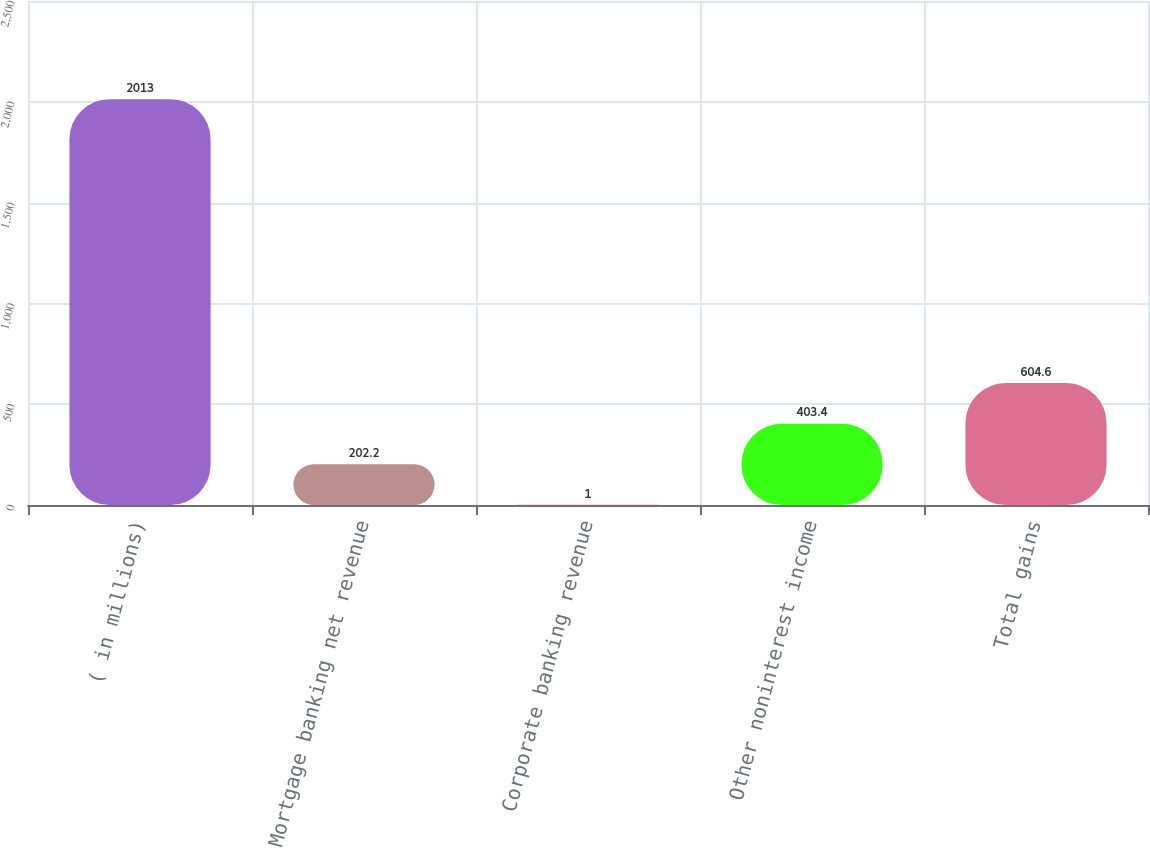Convert chart. <chart><loc_0><loc_0><loc_500><loc_500><bar_chart><fcel>( in millions)<fcel>Mortgage banking net revenue<fcel>Corporate banking revenue<fcel>Other noninterest income<fcel>Total gains<nl><fcel>2013<fcel>202.2<fcel>1<fcel>403.4<fcel>604.6<nl></chart> 